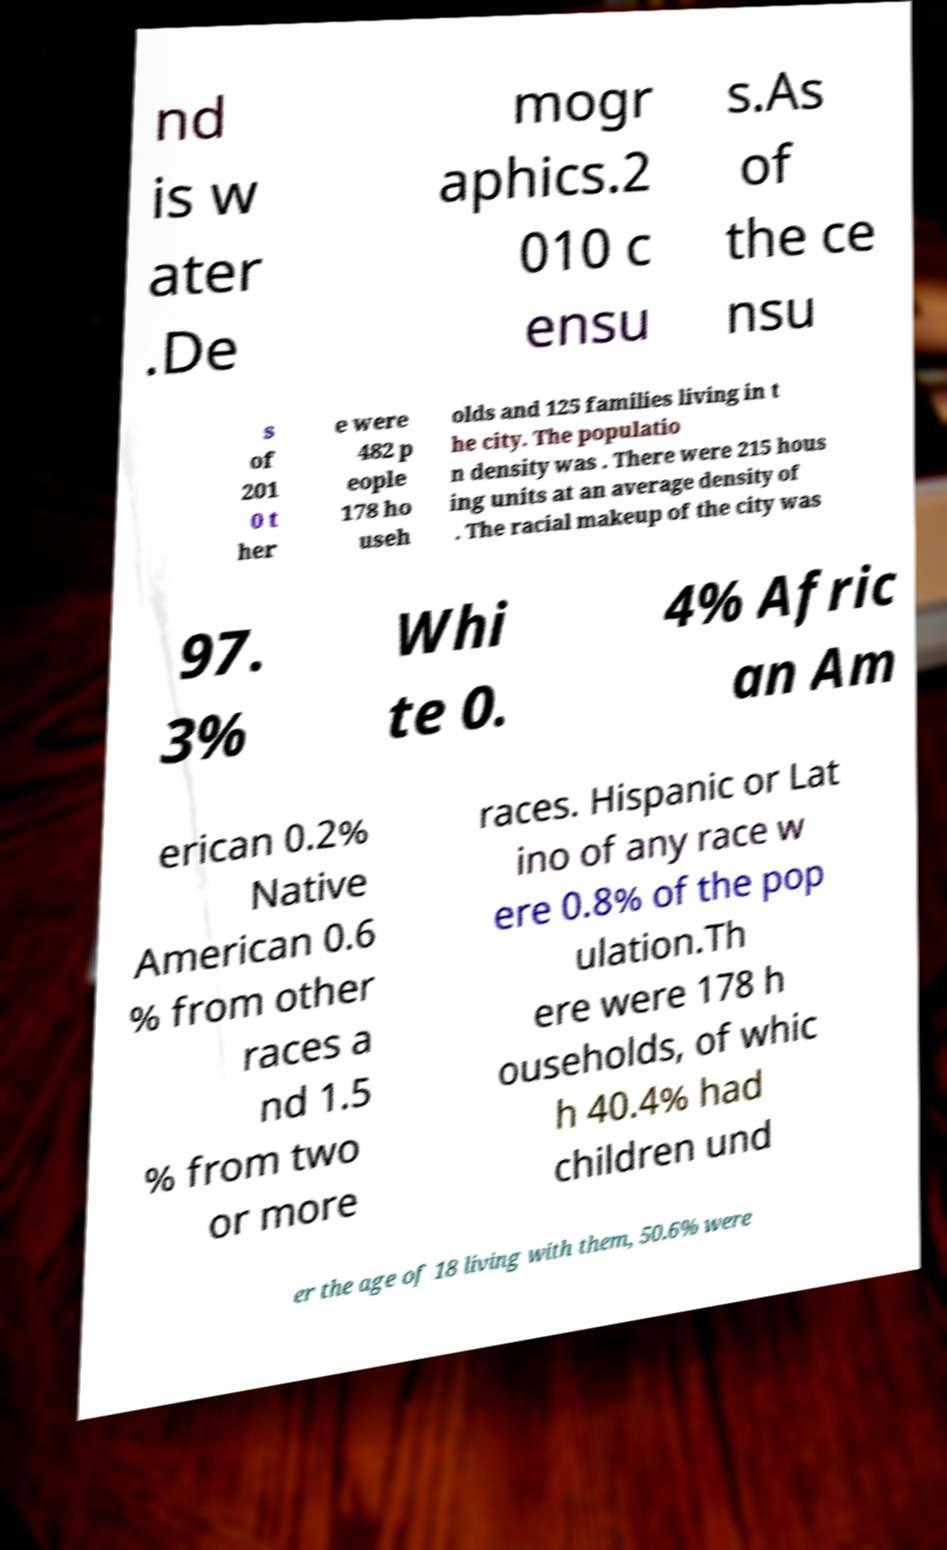Could you extract and type out the text from this image? nd is w ater .De mogr aphics.2 010 c ensu s.As of the ce nsu s of 201 0 t her e were 482 p eople 178 ho useh olds and 125 families living in t he city. The populatio n density was . There were 215 hous ing units at an average density of . The racial makeup of the city was 97. 3% Whi te 0. 4% Afric an Am erican 0.2% Native American 0.6 % from other races a nd 1.5 % from two or more races. Hispanic or Lat ino of any race w ere 0.8% of the pop ulation.Th ere were 178 h ouseholds, of whic h 40.4% had children und er the age of 18 living with them, 50.6% were 